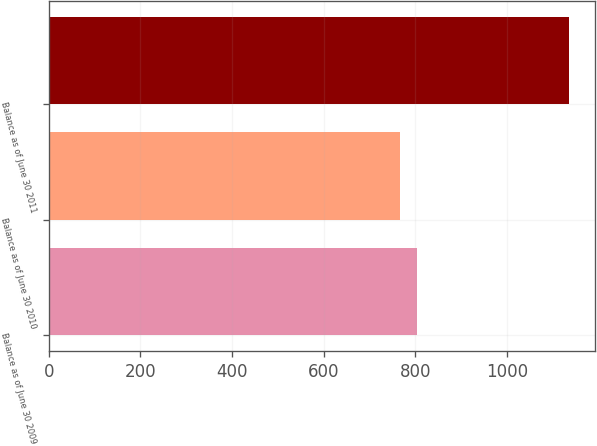<chart> <loc_0><loc_0><loc_500><loc_500><bar_chart><fcel>Balance as of June 30 2009<fcel>Balance as of June 30 2010<fcel>Balance as of June 30 2011<nl><fcel>803.86<fcel>767.2<fcel>1133.8<nl></chart> 